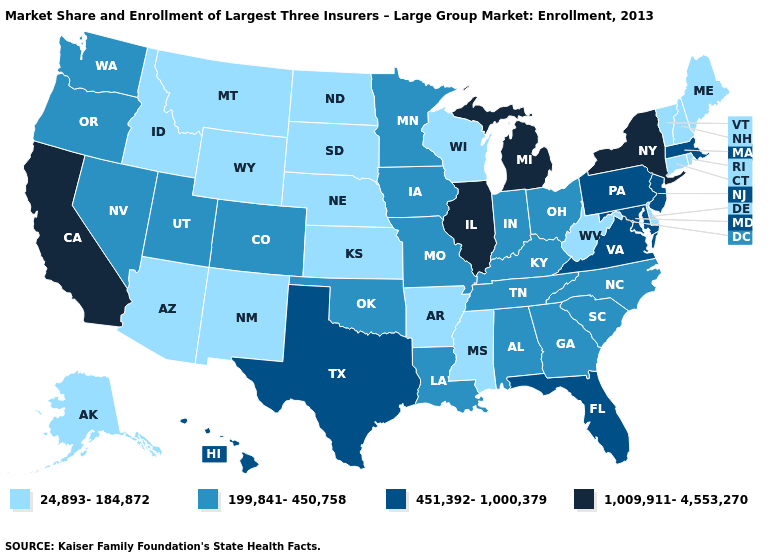What is the highest value in states that border Delaware?
Quick response, please. 451,392-1,000,379. What is the value of Hawaii?
Answer briefly. 451,392-1,000,379. What is the lowest value in the South?
Answer briefly. 24,893-184,872. How many symbols are there in the legend?
Quick response, please. 4. What is the value of Virginia?
Keep it brief. 451,392-1,000,379. Name the states that have a value in the range 199,841-450,758?
Write a very short answer. Alabama, Colorado, Georgia, Indiana, Iowa, Kentucky, Louisiana, Minnesota, Missouri, Nevada, North Carolina, Ohio, Oklahoma, Oregon, South Carolina, Tennessee, Utah, Washington. Which states have the lowest value in the USA?
Short answer required. Alaska, Arizona, Arkansas, Connecticut, Delaware, Idaho, Kansas, Maine, Mississippi, Montana, Nebraska, New Hampshire, New Mexico, North Dakota, Rhode Island, South Dakota, Vermont, West Virginia, Wisconsin, Wyoming. Which states have the lowest value in the West?
Be succinct. Alaska, Arizona, Idaho, Montana, New Mexico, Wyoming. What is the lowest value in states that border New Mexico?
Quick response, please. 24,893-184,872. How many symbols are there in the legend?
Quick response, please. 4. What is the lowest value in states that border Illinois?
Write a very short answer. 24,893-184,872. Does the map have missing data?
Short answer required. No. Does Oregon have a lower value than Virginia?
Quick response, please. Yes. What is the value of Nebraska?
Keep it brief. 24,893-184,872. 